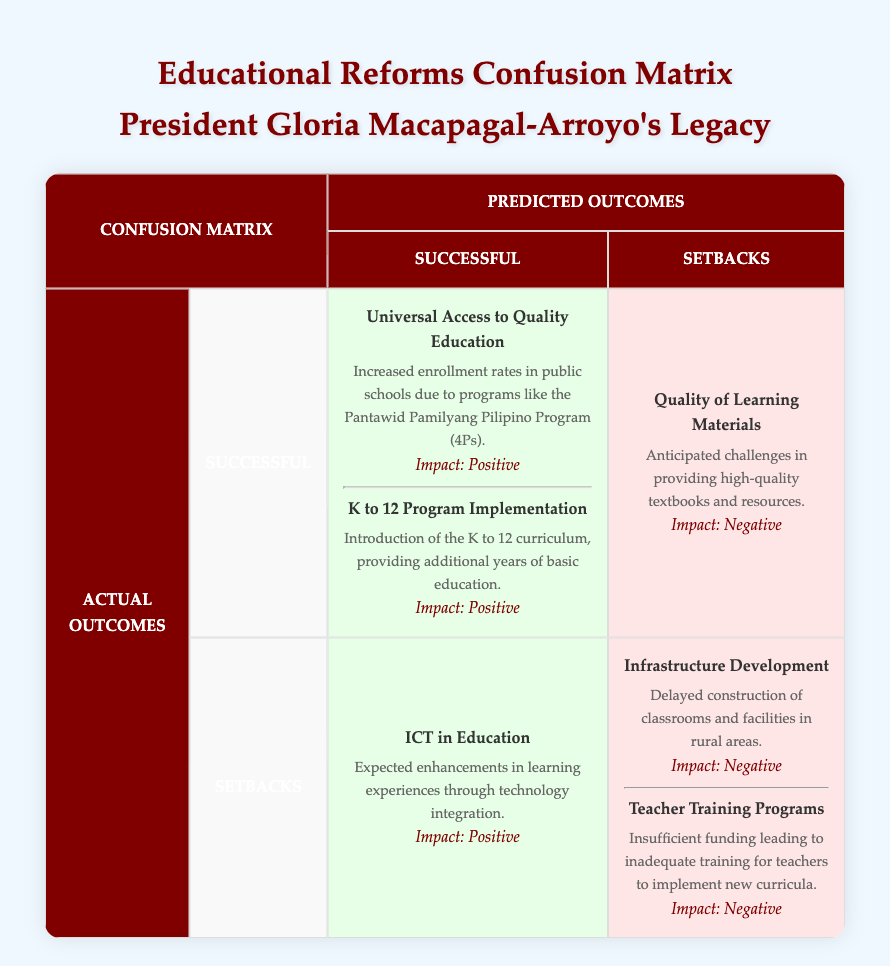What are the two successful actual outcomes listed in the table? The table identifies Universal Access to Quality Education and K to 12 Program Implementation as the two successful actual outcomes. They are explicitly listed under the "Actual Outcomes" section as "Successful."
Answer: Universal Access to Quality Education, K to 12 Program Implementation What was the anticipated challenge related to Quality of Learning Materials? The table indicates that there are expected challenges in providing high-quality textbooks and resources, which is specifically mentioned under the "Predicted Outcomes" as a setback.
Answer: Anticipated challenges in providing high-quality textbooks and resources How many setbacks were predicted in the table? By reviewing the "Predicted Outcomes" section of the table, one can see that there is one setback mentioned, which is the Quality of Learning Materials.
Answer: 1 Was the ICT in Education policy categorized as a successful outcome or a setback? The ICT in Education policy is categorized under the "Successful" predicted outcomes in the table. This can be verified by checking the relevant section of the matrix.
Answer: Successful outcome Which actual outcome had a negative impact due to insufficient funding in training? The table reveals that the Teacher Training Programs faced a negative impact due to insufficient funding, as this outcome is listed under the "Actual Outcomes" setbacks.
Answer: Teacher Training Programs Compare the number of successful outcomes to setbacks in actual outcomes. Which is greater? The table shows that there are two successful outcomes (Universal Access to Quality Education and K to 12 Program Implementation) and two setbacks (Infrastructure Development and Teacher Training Programs) in actual outcomes. Since both categories have the same number, we conclude neither is greater.
Answer: Neither is greater What is the impact associated with the K to 12 Program Implementation policy? The K to 12 Program Implementation policy is stated to have a "Positive" impact according to the description under actual outcomes. One can find this information in the relevant section of the table.
Answer: Positive If we consider both actual outcomes and predicted outcomes, how many successful outcomes are listed in total? According to the table, there are two successful actual outcomes and one successful predicted outcome. Adding these gives a total of three successful outcomes. This can be calculated by counting the entries in both categories.
Answer: 3 